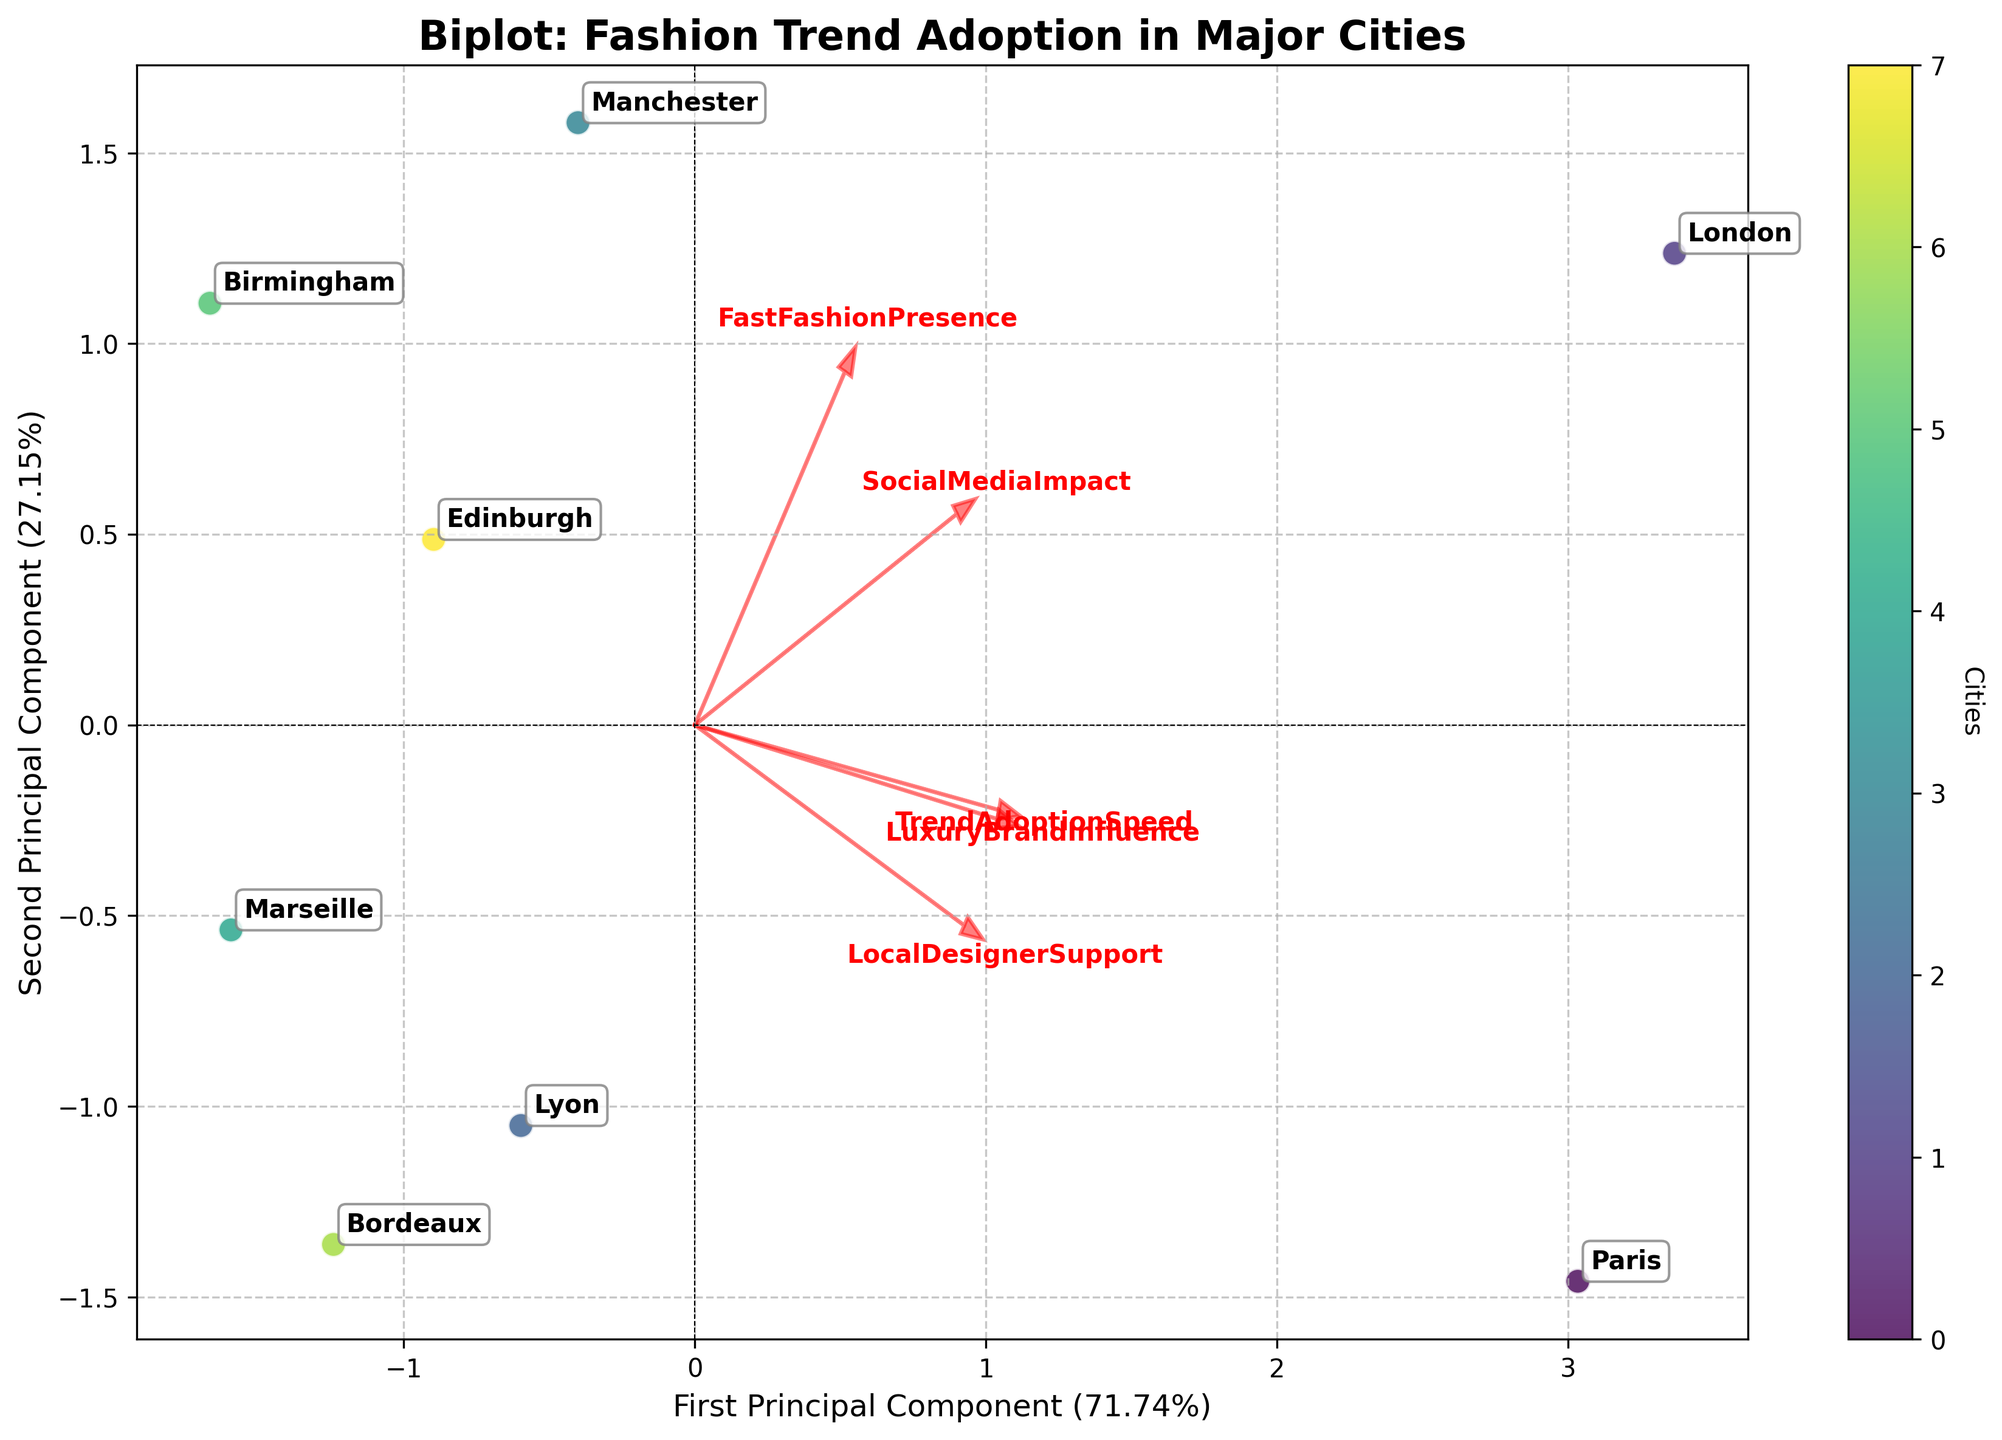What is the title of the figure? The title of the figure is prominently displayed at the top and specifies the focus of the plot. By looking at the top of the plot, you can see that the title is "Biplot: Fashion Trend Adoption in Major Cities".
Answer: Biplot: Fashion Trend Adoption in Major Cities How many cities are plotted in the figure? Each city is represented by a distinct point on the biplot. Looking at the annotations, you can see city names for each data point. Counting the unique names of the cities, there are 8 cities plotted.
Answer: 8 Which city's trend adoption speed is most closely associated with the first principal component? The principal components are shown on the axes, where cities with a high value along one axis are closely associated with that component. Paris appears to have the highest projection on the first principal component.
Answer: Paris Which two cities appear closest to each other on the biplot? Examining the distances between data points, London and Manchester are closer to each other compared to other city pairs. This suggests that their fashion trend adoption profiles are more similar.
Answer: London and Manchester Which feature vector has the largest loading on the first principal component? Each feature vector is represented by a red arrow. By comparing the lengths of the arrows along the first principal component axis, the "TrendAdoptionSpeed" vector has the longest projection.
Answer: TrendAdoptionSpeed Which city has a higher value on the second principal component, Lyon or Bordeaux? The second principal component corresponds to the y-axis. By checking the coordinates of Lyon and Bordeaux, Lyon lies higher along the y-axis.
Answer: Lyon How are 'LuxuryBrandInfluence' and 'SocialMediaImpact' aligned relative to each other on the biplot? These two features are represented by arrows. Observing their directions, they are somewhat aligned but not perfectly parallel; they point in broadly similar but slightly different directions.
Answer: Slightly similar directions What explains the horizontal separation of Paris from other cities? The large positive loading of 'TrendAdoptionSpeed' and 'LuxuryBrandInfluence' explains why Paris is separated horizontally. Paris is likely to have high values for these features.
Answer: TrendAdoptionSpeed and LuxuryBrandInfluence If a city were to have a high fast fashion presence and high local designer support, where would it likely appear on the plot? 'FastFashionPresence' and 'LocalDesignerSupport' vectors' directions would suggest that such a city would project onto an area that aligns positively with both vectors, thus appearing somewhere in the quadrant where both vectors are extending.
Answer: The positive quadrant where both vectors extend 